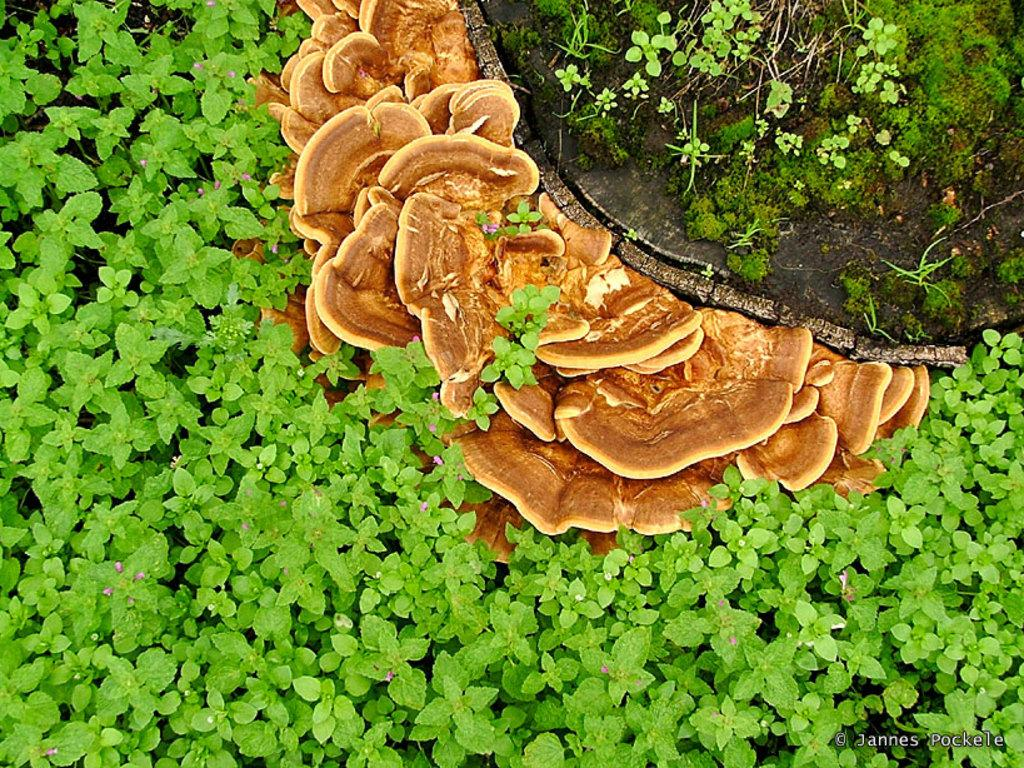What type of living organisms can be seen in the image? Plants, flowers, and mushrooms are visible in the image. Can you describe the specific flora present in the image? There are flowers and mushrooms in the image. Is there any text present in the image? Yes, there is text in the bottom right side of the image. How many girls are playing with the mushrooms in the image? There are no girls present in the image; it features plants, flowers, and mushrooms. What type of memory is being used to store the image? The question refers to a concept that is not present in the image, as it is a visual representation and not a digital file or physical object with memory storage. 